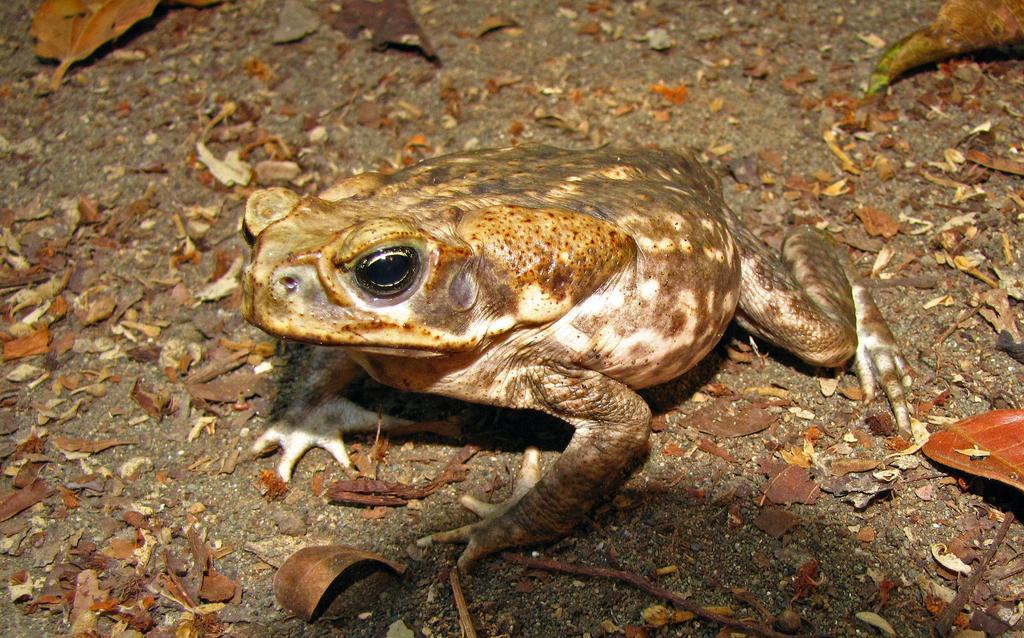Could you give a brief overview of what you see in this image? In this image there is a frog on the land having few dried leaves on it. 